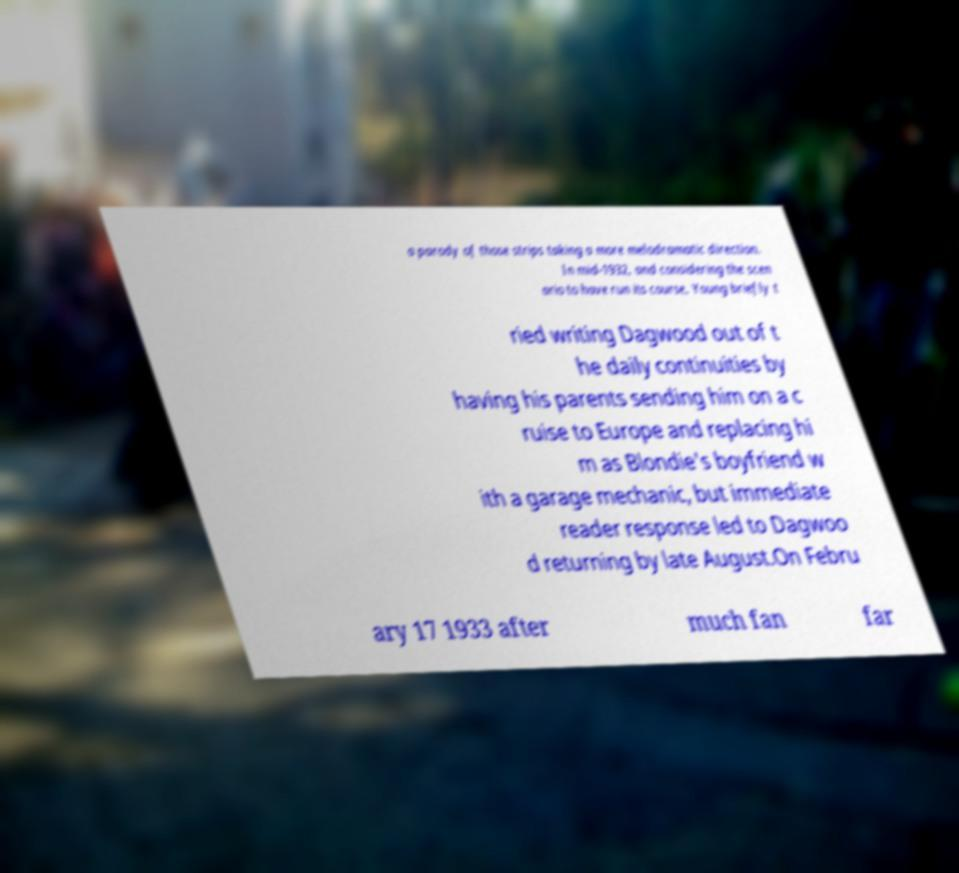What messages or text are displayed in this image? I need them in a readable, typed format. a parody of those strips taking a more melodramatic direction. In mid-1932, and considering the scen ario to have run its course, Young briefly t ried writing Dagwood out of t he daily continuities by having his parents sending him on a c ruise to Europe and replacing hi m as Blondie's boyfriend w ith a garage mechanic, but immediate reader response led to Dagwoo d returning by late August.On Febru ary 17 1933 after much fan far 